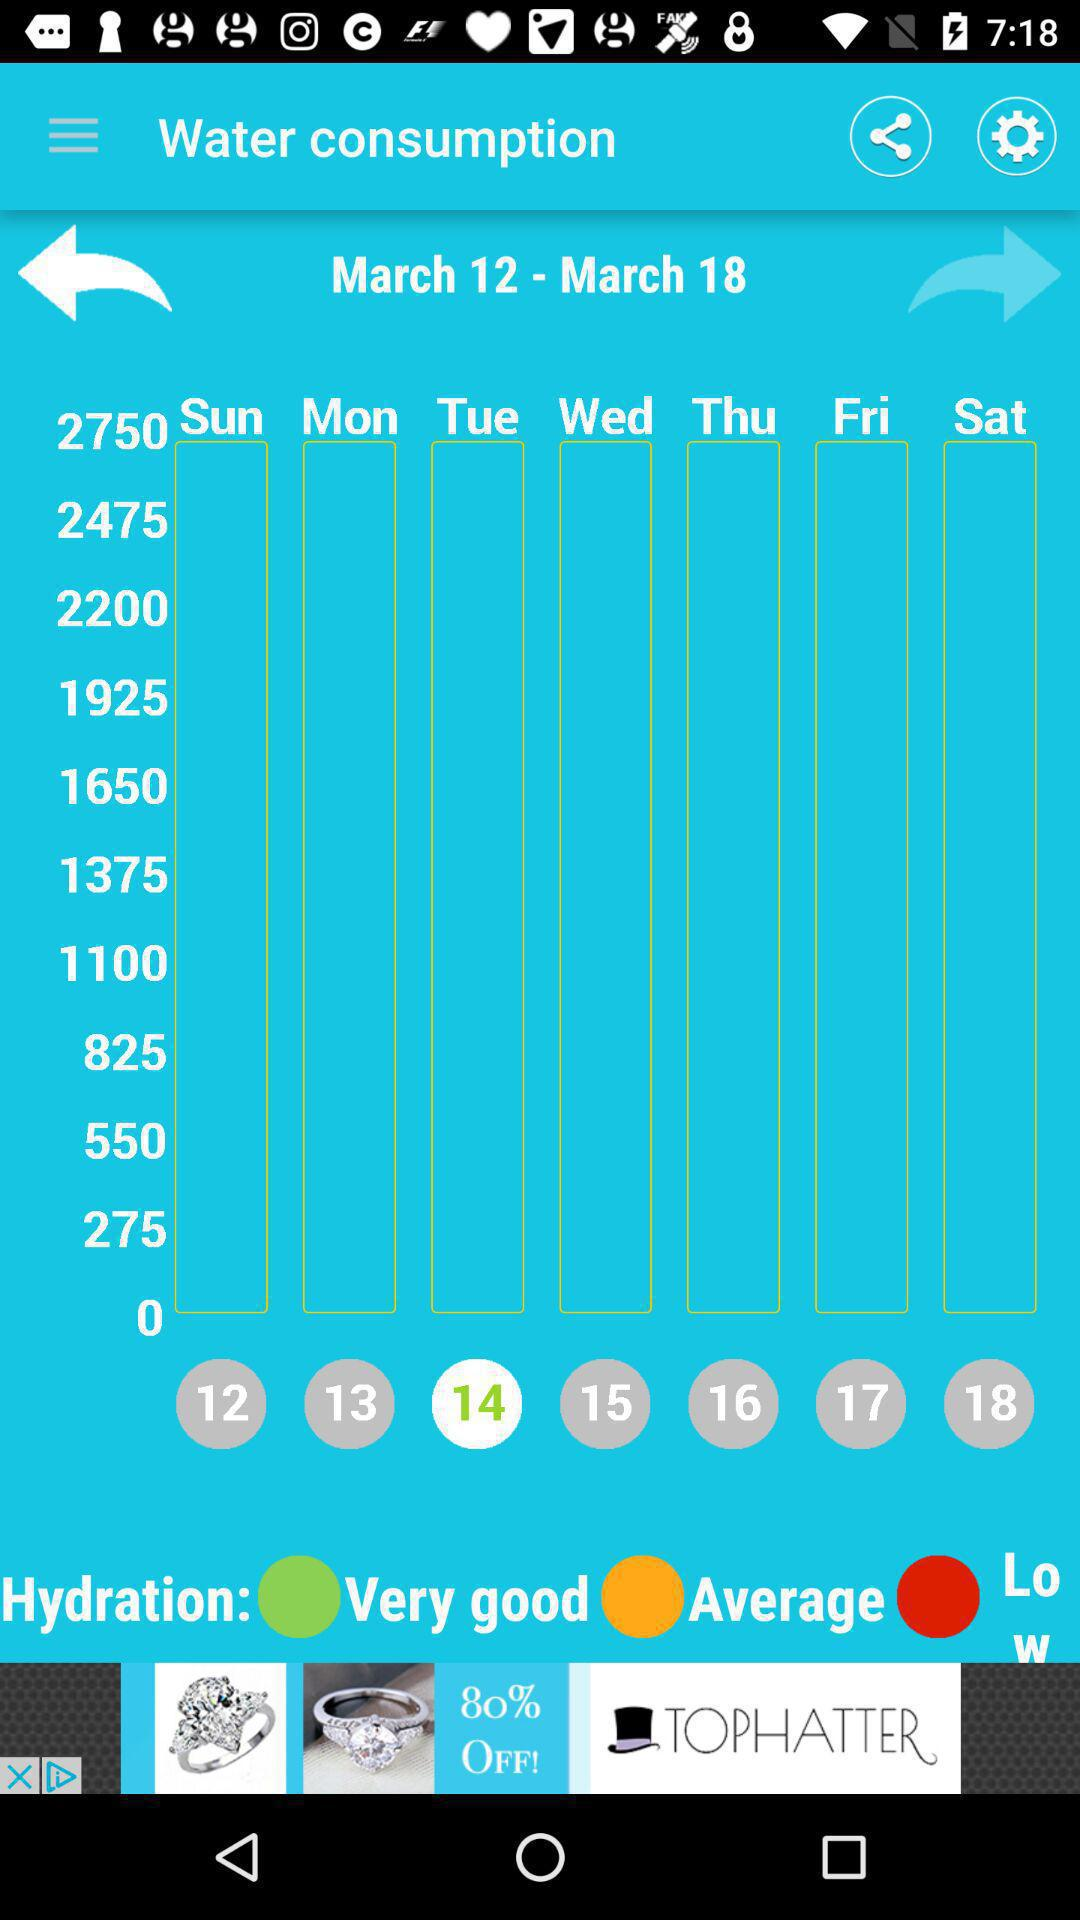Which day has been selected? The selected day is Tuesday. 